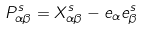<formula> <loc_0><loc_0><loc_500><loc_500>P ^ { s } _ { \alpha \beta } = X ^ { s } _ { \alpha \beta } - e _ { \alpha } e ^ { s } _ { \beta }</formula> 